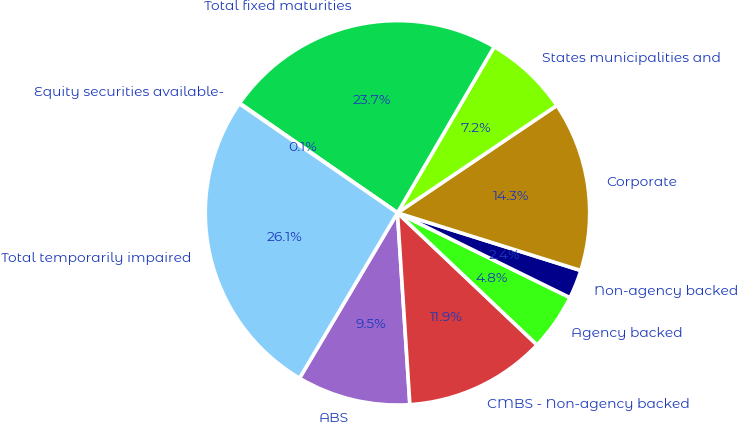Convert chart. <chart><loc_0><loc_0><loc_500><loc_500><pie_chart><fcel>ABS<fcel>CMBS - Non-agency backed<fcel>Agency backed<fcel>Non-agency backed<fcel>Corporate<fcel>States municipalities and<fcel>Total fixed maturities<fcel>Equity securities available-<fcel>Total temporarily impaired<nl><fcel>9.54%<fcel>11.91%<fcel>4.79%<fcel>2.42%<fcel>14.29%<fcel>7.17%<fcel>23.73%<fcel>0.05%<fcel>26.1%<nl></chart> 